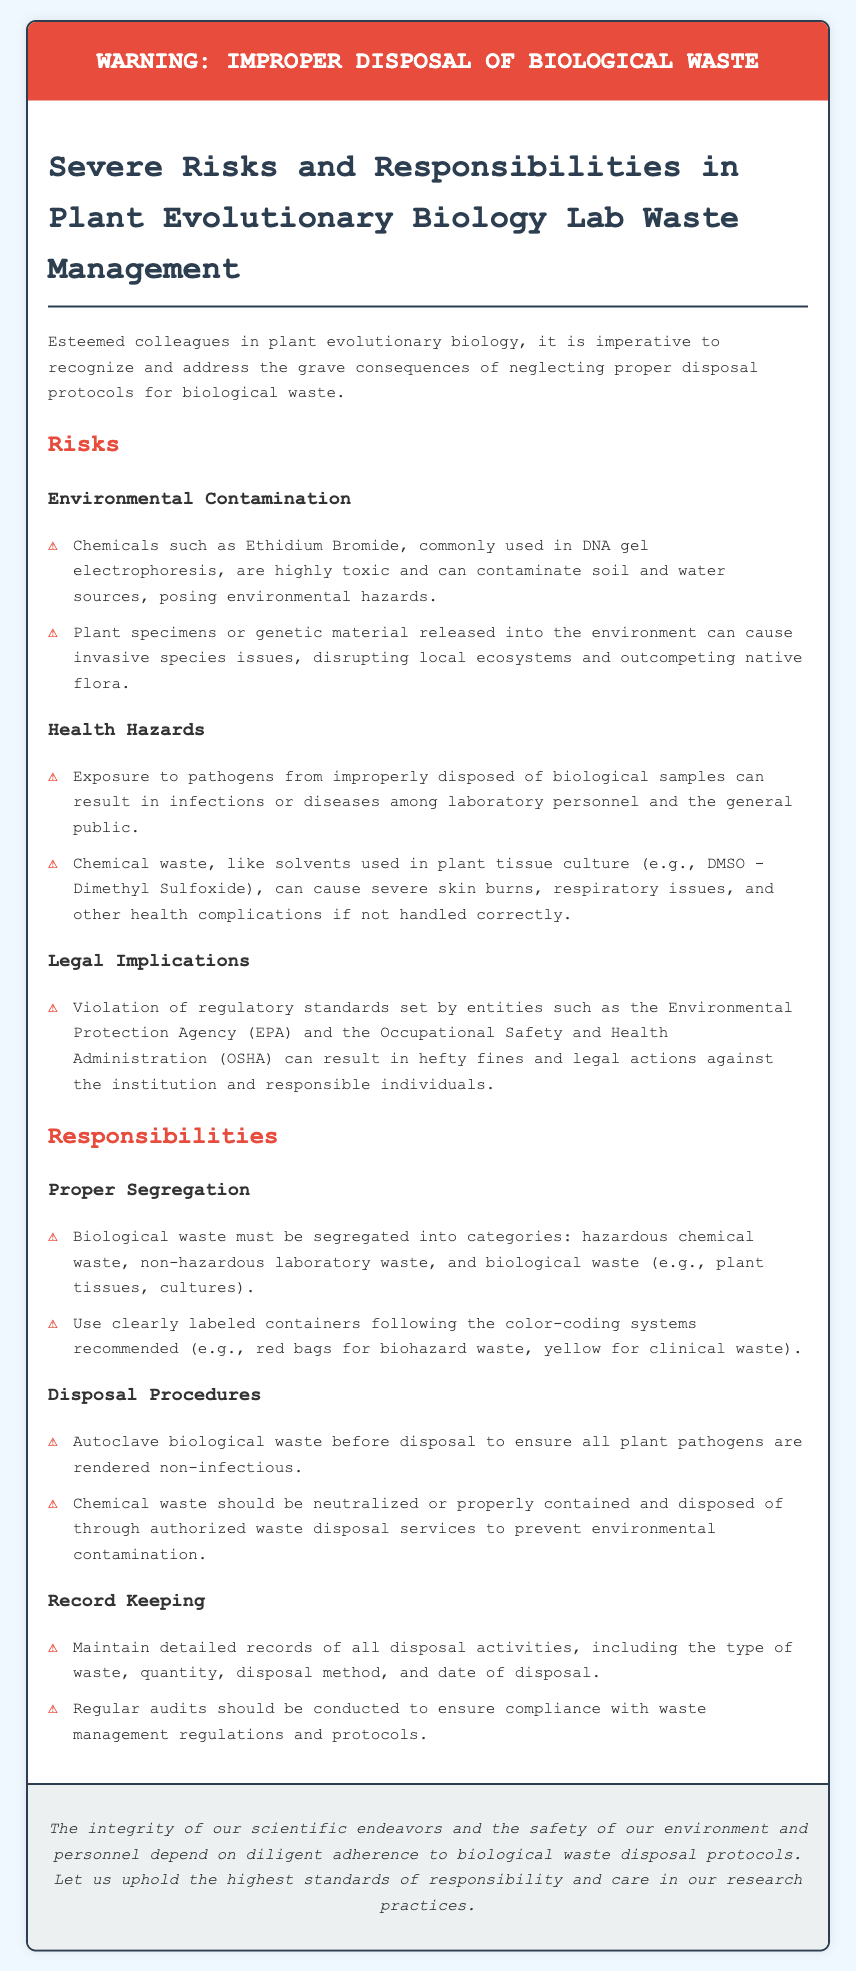What is the title of the document? The title is found in the header of the document, which states the main warning concern.
Answer: Biological Waste Disposal Warning What chemical is mentioned as toxic in the document? The document mentions a specific chemical used in laboratory processes that poses environmental risks.
Answer: Ethidium Bromide What should biological waste be autoclaved for? The document specifies a procedure to ensure safety concerning biological waste.
Answer: To ensure all plant pathogens are rendered non-infectious What type of waste should be placed in red bags? The document provides a color-coded system for categorizing waste types.
Answer: Biohazard waste What federal agency is mentioned in connection to legal implications? The document lists organizations responsible for setting regulations relevant to waste disposal.
Answer: Environmental Protection Agency (EPA) Explain the purpose of maintaining detailed records in waste disposal. The document discusses the importance of recording disposal activities to comply with regulations.
Answer: Ensure compliance with waste management regulations Why is exposure to pathogens a health hazard in improper disposal? The document outlines health risks due to handling improperly disposed biological samples.
Answer: Can result in infections or diseases What should be done with chemical waste before disposal? The document informs on the treatment of chemical waste to prevent environmental issues.
Answer: Should be neutralized or properly contained What is the background color of the document? The document's styling specifies a particular color for the body that is mentioned in its style section.
Answer: Light blue (f0f8ff) How often should audits be conducted? The document mentions a procedure regarding the frequency of compliance checks.
Answer: Regularly 